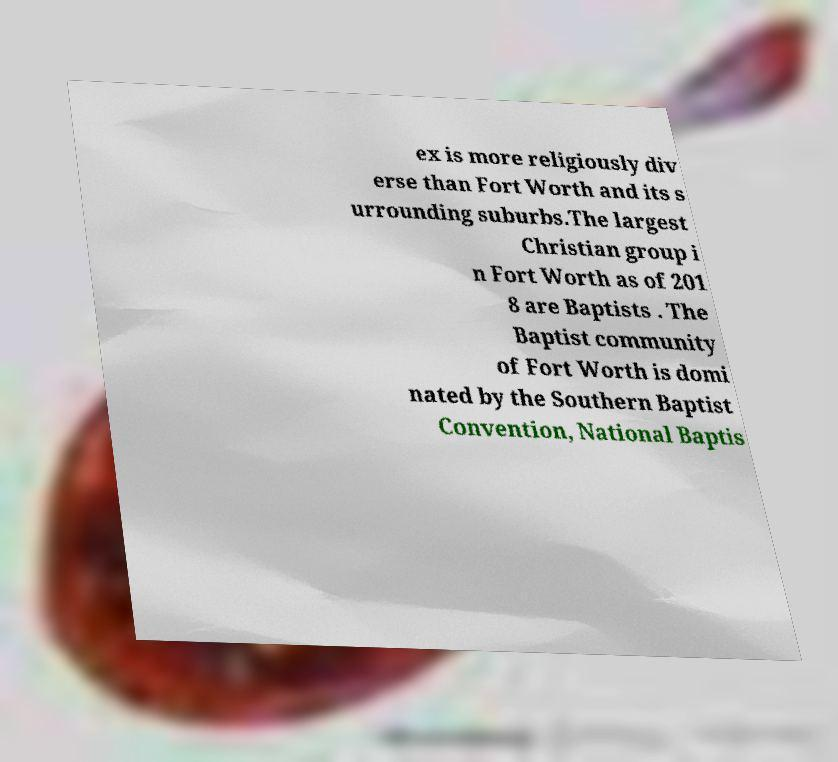There's text embedded in this image that I need extracted. Can you transcribe it verbatim? ex is more religiously div erse than Fort Worth and its s urrounding suburbs.The largest Christian group i n Fort Worth as of 201 8 are Baptists . The Baptist community of Fort Worth is domi nated by the Southern Baptist Convention, National Baptis 